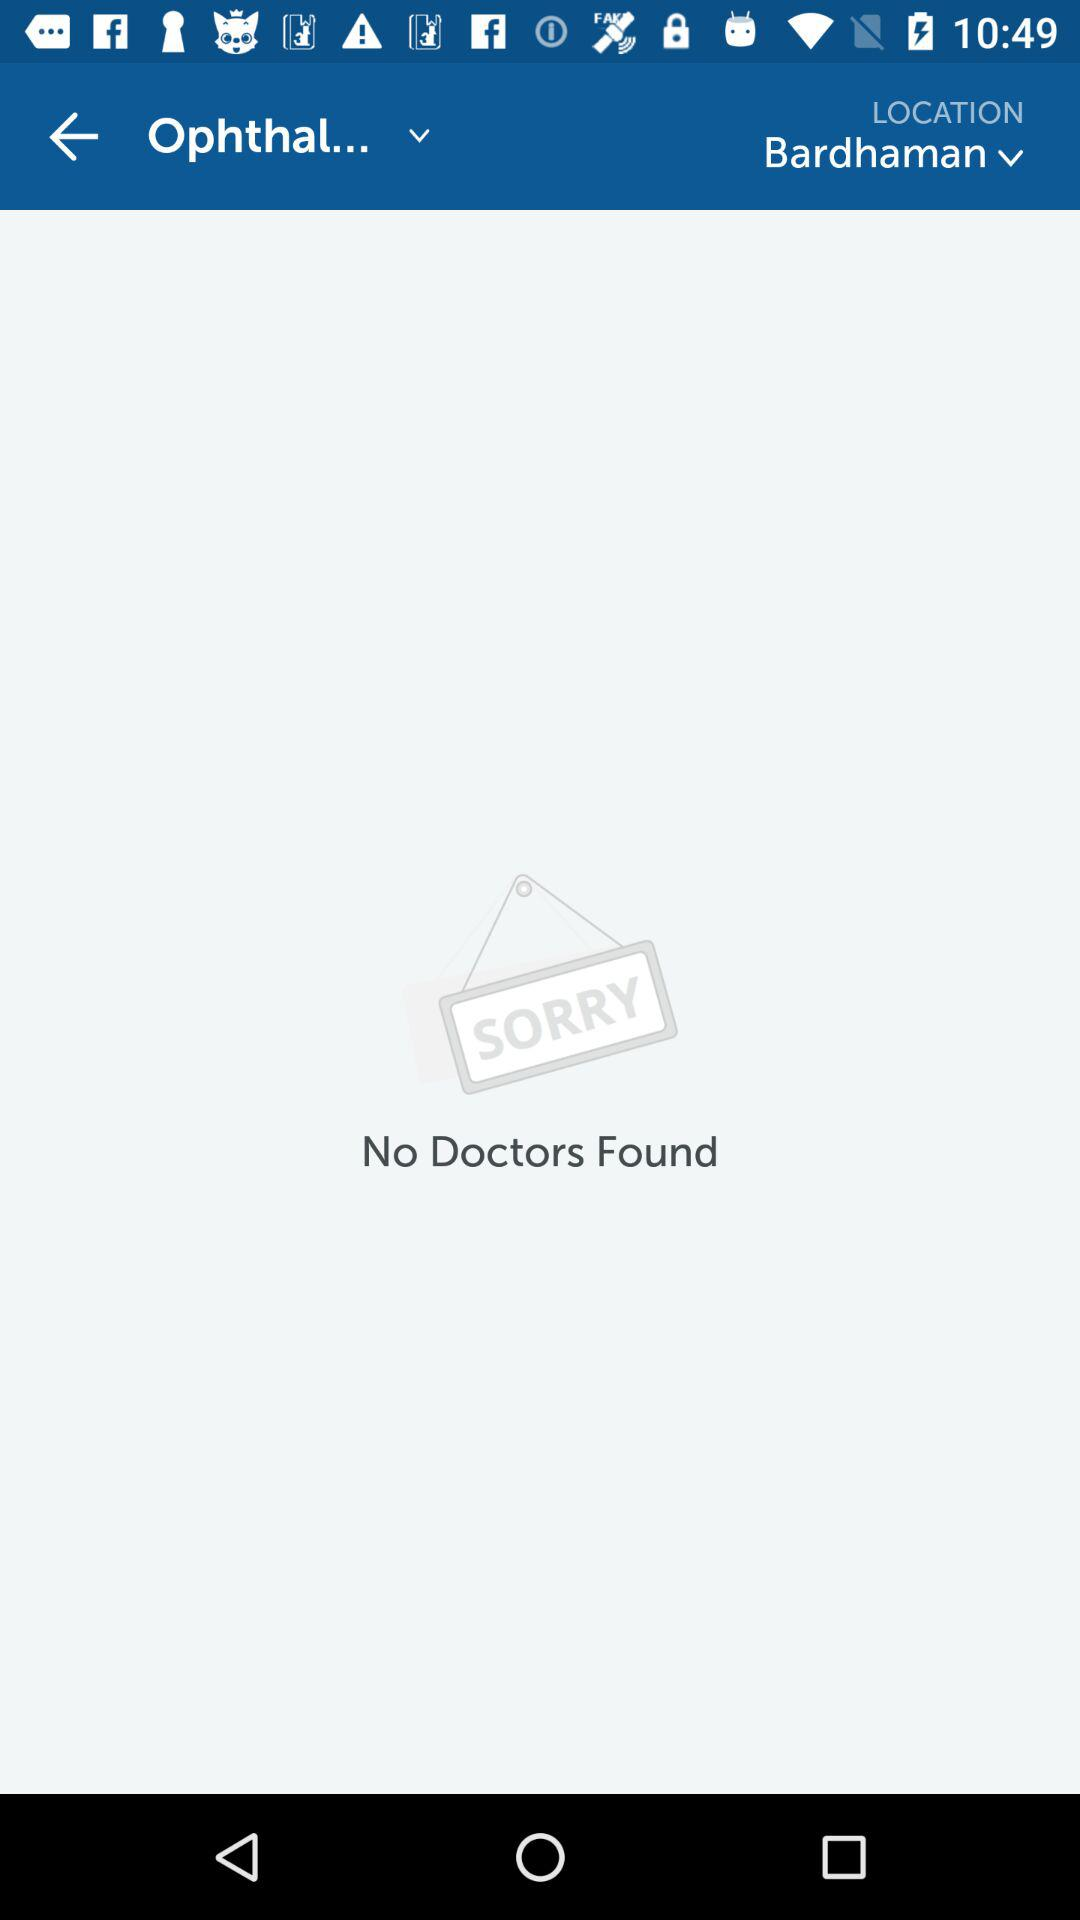What is the location? The location is Bardhaman. 